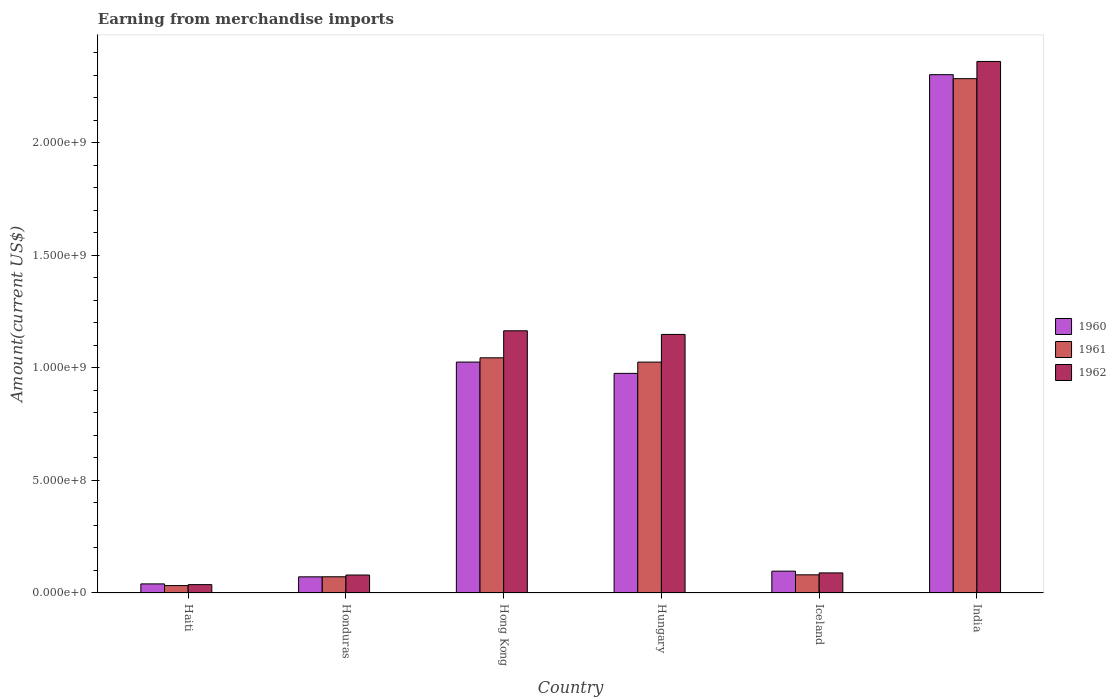Are the number of bars per tick equal to the number of legend labels?
Keep it short and to the point. Yes. Are the number of bars on each tick of the X-axis equal?
Your answer should be compact. Yes. How many bars are there on the 6th tick from the left?
Ensure brevity in your answer.  3. What is the label of the 1st group of bars from the left?
Provide a succinct answer. Haiti. What is the amount earned from merchandise imports in 1962 in India?
Ensure brevity in your answer.  2.36e+09. Across all countries, what is the maximum amount earned from merchandise imports in 1960?
Offer a terse response. 2.30e+09. Across all countries, what is the minimum amount earned from merchandise imports in 1961?
Provide a succinct answer. 3.29e+07. In which country was the amount earned from merchandise imports in 1960 maximum?
Your answer should be compact. India. In which country was the amount earned from merchandise imports in 1962 minimum?
Keep it short and to the point. Haiti. What is the total amount earned from merchandise imports in 1961 in the graph?
Your response must be concise. 4.54e+09. What is the difference between the amount earned from merchandise imports in 1961 in Hong Kong and that in Hungary?
Give a very brief answer. 1.91e+07. What is the difference between the amount earned from merchandise imports in 1961 in Haiti and the amount earned from merchandise imports in 1962 in Honduras?
Ensure brevity in your answer.  -4.69e+07. What is the average amount earned from merchandise imports in 1962 per country?
Offer a terse response. 8.14e+08. What is the difference between the amount earned from merchandise imports of/in 1961 and amount earned from merchandise imports of/in 1962 in Honduras?
Give a very brief answer. -7.75e+06. What is the ratio of the amount earned from merchandise imports in 1962 in Hungary to that in Iceland?
Your response must be concise. 12.87. Is the amount earned from merchandise imports in 1960 in Honduras less than that in Iceland?
Your answer should be compact. Yes. What is the difference between the highest and the second highest amount earned from merchandise imports in 1962?
Give a very brief answer. 1.20e+09. What is the difference between the highest and the lowest amount earned from merchandise imports in 1962?
Give a very brief answer. 2.32e+09. What does the 2nd bar from the left in Haiti represents?
Give a very brief answer. 1961. What does the 1st bar from the right in Hong Kong represents?
Offer a very short reply. 1962. Is it the case that in every country, the sum of the amount earned from merchandise imports in 1962 and amount earned from merchandise imports in 1960 is greater than the amount earned from merchandise imports in 1961?
Make the answer very short. Yes. How many bars are there?
Give a very brief answer. 18. What is the difference between two consecutive major ticks on the Y-axis?
Provide a short and direct response. 5.00e+08. Does the graph contain grids?
Provide a succinct answer. No. How many legend labels are there?
Make the answer very short. 3. How are the legend labels stacked?
Provide a succinct answer. Vertical. What is the title of the graph?
Offer a terse response. Earning from merchandise imports. Does "1962" appear as one of the legend labels in the graph?
Offer a terse response. Yes. What is the label or title of the X-axis?
Provide a short and direct response. Country. What is the label or title of the Y-axis?
Your response must be concise. Amount(current US$). What is the Amount(current US$) in 1960 in Haiti?
Your answer should be compact. 4.04e+07. What is the Amount(current US$) of 1961 in Haiti?
Offer a terse response. 3.29e+07. What is the Amount(current US$) in 1962 in Haiti?
Make the answer very short. 3.72e+07. What is the Amount(current US$) in 1960 in Honduras?
Provide a short and direct response. 7.18e+07. What is the Amount(current US$) in 1961 in Honduras?
Keep it short and to the point. 7.20e+07. What is the Amount(current US$) of 1962 in Honduras?
Provide a short and direct response. 7.98e+07. What is the Amount(current US$) in 1960 in Hong Kong?
Your response must be concise. 1.03e+09. What is the Amount(current US$) of 1961 in Hong Kong?
Your response must be concise. 1.05e+09. What is the Amount(current US$) in 1962 in Hong Kong?
Provide a succinct answer. 1.17e+09. What is the Amount(current US$) of 1960 in Hungary?
Ensure brevity in your answer.  9.76e+08. What is the Amount(current US$) of 1961 in Hungary?
Provide a succinct answer. 1.03e+09. What is the Amount(current US$) in 1962 in Hungary?
Your response must be concise. 1.15e+09. What is the Amount(current US$) in 1960 in Iceland?
Provide a succinct answer. 9.70e+07. What is the Amount(current US$) of 1961 in Iceland?
Ensure brevity in your answer.  8.08e+07. What is the Amount(current US$) in 1962 in Iceland?
Ensure brevity in your answer.  8.93e+07. What is the Amount(current US$) of 1960 in India?
Offer a very short reply. 2.30e+09. What is the Amount(current US$) in 1961 in India?
Ensure brevity in your answer.  2.29e+09. What is the Amount(current US$) of 1962 in India?
Your answer should be very brief. 2.36e+09. Across all countries, what is the maximum Amount(current US$) of 1960?
Your answer should be very brief. 2.30e+09. Across all countries, what is the maximum Amount(current US$) in 1961?
Ensure brevity in your answer.  2.29e+09. Across all countries, what is the maximum Amount(current US$) in 1962?
Provide a succinct answer. 2.36e+09. Across all countries, what is the minimum Amount(current US$) of 1960?
Offer a very short reply. 4.04e+07. Across all countries, what is the minimum Amount(current US$) of 1961?
Offer a terse response. 3.29e+07. Across all countries, what is the minimum Amount(current US$) of 1962?
Give a very brief answer. 3.72e+07. What is the total Amount(current US$) of 1960 in the graph?
Your answer should be compact. 4.51e+09. What is the total Amount(current US$) of 1961 in the graph?
Your answer should be compact. 4.54e+09. What is the total Amount(current US$) of 1962 in the graph?
Give a very brief answer. 4.88e+09. What is the difference between the Amount(current US$) of 1960 in Haiti and that in Honduras?
Offer a very short reply. -3.14e+07. What is the difference between the Amount(current US$) in 1961 in Haiti and that in Honduras?
Give a very brief answer. -3.92e+07. What is the difference between the Amount(current US$) of 1962 in Haiti and that in Honduras?
Ensure brevity in your answer.  -4.26e+07. What is the difference between the Amount(current US$) of 1960 in Haiti and that in Hong Kong?
Offer a terse response. -9.86e+08. What is the difference between the Amount(current US$) of 1961 in Haiti and that in Hong Kong?
Ensure brevity in your answer.  -1.01e+09. What is the difference between the Amount(current US$) in 1962 in Haiti and that in Hong Kong?
Provide a succinct answer. -1.13e+09. What is the difference between the Amount(current US$) in 1960 in Haiti and that in Hungary?
Your response must be concise. -9.36e+08. What is the difference between the Amount(current US$) in 1961 in Haiti and that in Hungary?
Offer a very short reply. -9.93e+08. What is the difference between the Amount(current US$) of 1962 in Haiti and that in Hungary?
Your answer should be very brief. -1.11e+09. What is the difference between the Amount(current US$) of 1960 in Haiti and that in Iceland?
Your answer should be compact. -5.66e+07. What is the difference between the Amount(current US$) of 1961 in Haiti and that in Iceland?
Your answer should be very brief. -4.79e+07. What is the difference between the Amount(current US$) of 1962 in Haiti and that in Iceland?
Make the answer very short. -5.21e+07. What is the difference between the Amount(current US$) in 1960 in Haiti and that in India?
Your response must be concise. -2.26e+09. What is the difference between the Amount(current US$) in 1961 in Haiti and that in India?
Offer a very short reply. -2.25e+09. What is the difference between the Amount(current US$) of 1962 in Haiti and that in India?
Provide a succinct answer. -2.32e+09. What is the difference between the Amount(current US$) of 1960 in Honduras and that in Hong Kong?
Ensure brevity in your answer.  -9.54e+08. What is the difference between the Amount(current US$) of 1961 in Honduras and that in Hong Kong?
Your answer should be very brief. -9.73e+08. What is the difference between the Amount(current US$) in 1962 in Honduras and that in Hong Kong?
Offer a very short reply. -1.09e+09. What is the difference between the Amount(current US$) in 1960 in Honduras and that in Hungary?
Offer a very short reply. -9.04e+08. What is the difference between the Amount(current US$) in 1961 in Honduras and that in Hungary?
Provide a short and direct response. -9.54e+08. What is the difference between the Amount(current US$) of 1962 in Honduras and that in Hungary?
Offer a very short reply. -1.07e+09. What is the difference between the Amount(current US$) in 1960 in Honduras and that in Iceland?
Your answer should be compact. -2.52e+07. What is the difference between the Amount(current US$) in 1961 in Honduras and that in Iceland?
Ensure brevity in your answer.  -8.71e+06. What is the difference between the Amount(current US$) of 1962 in Honduras and that in Iceland?
Keep it short and to the point. -9.50e+06. What is the difference between the Amount(current US$) in 1960 in Honduras and that in India?
Make the answer very short. -2.23e+09. What is the difference between the Amount(current US$) in 1961 in Honduras and that in India?
Your answer should be compact. -2.21e+09. What is the difference between the Amount(current US$) in 1962 in Honduras and that in India?
Provide a succinct answer. -2.28e+09. What is the difference between the Amount(current US$) of 1960 in Hong Kong and that in Hungary?
Offer a very short reply. 5.02e+07. What is the difference between the Amount(current US$) of 1961 in Hong Kong and that in Hungary?
Give a very brief answer. 1.91e+07. What is the difference between the Amount(current US$) in 1962 in Hong Kong and that in Hungary?
Your answer should be very brief. 1.62e+07. What is the difference between the Amount(current US$) in 1960 in Hong Kong and that in Iceland?
Your answer should be very brief. 9.29e+08. What is the difference between the Amount(current US$) in 1961 in Hong Kong and that in Iceland?
Provide a succinct answer. 9.64e+08. What is the difference between the Amount(current US$) in 1962 in Hong Kong and that in Iceland?
Offer a terse response. 1.08e+09. What is the difference between the Amount(current US$) of 1960 in Hong Kong and that in India?
Give a very brief answer. -1.28e+09. What is the difference between the Amount(current US$) of 1961 in Hong Kong and that in India?
Ensure brevity in your answer.  -1.24e+09. What is the difference between the Amount(current US$) of 1962 in Hong Kong and that in India?
Offer a terse response. -1.20e+09. What is the difference between the Amount(current US$) in 1960 in Hungary and that in Iceland?
Your response must be concise. 8.79e+08. What is the difference between the Amount(current US$) in 1961 in Hungary and that in Iceland?
Make the answer very short. 9.45e+08. What is the difference between the Amount(current US$) in 1962 in Hungary and that in Iceland?
Your response must be concise. 1.06e+09. What is the difference between the Amount(current US$) of 1960 in Hungary and that in India?
Make the answer very short. -1.33e+09. What is the difference between the Amount(current US$) in 1961 in Hungary and that in India?
Provide a succinct answer. -1.26e+09. What is the difference between the Amount(current US$) of 1962 in Hungary and that in India?
Offer a very short reply. -1.21e+09. What is the difference between the Amount(current US$) of 1960 in Iceland and that in India?
Offer a terse response. -2.21e+09. What is the difference between the Amount(current US$) of 1961 in Iceland and that in India?
Give a very brief answer. -2.20e+09. What is the difference between the Amount(current US$) of 1962 in Iceland and that in India?
Provide a short and direct response. -2.27e+09. What is the difference between the Amount(current US$) of 1960 in Haiti and the Amount(current US$) of 1961 in Honduras?
Your answer should be compact. -3.17e+07. What is the difference between the Amount(current US$) of 1960 in Haiti and the Amount(current US$) of 1962 in Honduras?
Keep it short and to the point. -3.94e+07. What is the difference between the Amount(current US$) in 1961 in Haiti and the Amount(current US$) in 1962 in Honduras?
Your answer should be compact. -4.69e+07. What is the difference between the Amount(current US$) of 1960 in Haiti and the Amount(current US$) of 1961 in Hong Kong?
Make the answer very short. -1.00e+09. What is the difference between the Amount(current US$) in 1960 in Haiti and the Amount(current US$) in 1962 in Hong Kong?
Provide a short and direct response. -1.12e+09. What is the difference between the Amount(current US$) of 1961 in Haiti and the Amount(current US$) of 1962 in Hong Kong?
Ensure brevity in your answer.  -1.13e+09. What is the difference between the Amount(current US$) in 1960 in Haiti and the Amount(current US$) in 1961 in Hungary?
Give a very brief answer. -9.86e+08. What is the difference between the Amount(current US$) in 1960 in Haiti and the Amount(current US$) in 1962 in Hungary?
Your answer should be very brief. -1.11e+09. What is the difference between the Amount(current US$) of 1961 in Haiti and the Amount(current US$) of 1962 in Hungary?
Make the answer very short. -1.12e+09. What is the difference between the Amount(current US$) in 1960 in Haiti and the Amount(current US$) in 1961 in Iceland?
Make the answer very short. -4.04e+07. What is the difference between the Amount(current US$) of 1960 in Haiti and the Amount(current US$) of 1962 in Iceland?
Provide a short and direct response. -4.89e+07. What is the difference between the Amount(current US$) in 1961 in Haiti and the Amount(current US$) in 1962 in Iceland?
Provide a short and direct response. -5.64e+07. What is the difference between the Amount(current US$) in 1960 in Haiti and the Amount(current US$) in 1961 in India?
Give a very brief answer. -2.25e+09. What is the difference between the Amount(current US$) in 1960 in Haiti and the Amount(current US$) in 1962 in India?
Give a very brief answer. -2.32e+09. What is the difference between the Amount(current US$) of 1961 in Haiti and the Amount(current US$) of 1962 in India?
Provide a short and direct response. -2.33e+09. What is the difference between the Amount(current US$) of 1960 in Honduras and the Amount(current US$) of 1961 in Hong Kong?
Your response must be concise. -9.73e+08. What is the difference between the Amount(current US$) of 1960 in Honduras and the Amount(current US$) of 1962 in Hong Kong?
Make the answer very short. -1.09e+09. What is the difference between the Amount(current US$) in 1961 in Honduras and the Amount(current US$) in 1962 in Hong Kong?
Your answer should be very brief. -1.09e+09. What is the difference between the Amount(current US$) of 1960 in Honduras and the Amount(current US$) of 1961 in Hungary?
Provide a short and direct response. -9.54e+08. What is the difference between the Amount(current US$) of 1960 in Honduras and the Amount(current US$) of 1962 in Hungary?
Offer a terse response. -1.08e+09. What is the difference between the Amount(current US$) of 1961 in Honduras and the Amount(current US$) of 1962 in Hungary?
Keep it short and to the point. -1.08e+09. What is the difference between the Amount(current US$) of 1960 in Honduras and the Amount(current US$) of 1961 in Iceland?
Ensure brevity in your answer.  -8.96e+06. What is the difference between the Amount(current US$) in 1960 in Honduras and the Amount(current US$) in 1962 in Iceland?
Your answer should be compact. -1.75e+07. What is the difference between the Amount(current US$) of 1961 in Honduras and the Amount(current US$) of 1962 in Iceland?
Ensure brevity in your answer.  -1.73e+07. What is the difference between the Amount(current US$) of 1960 in Honduras and the Amount(current US$) of 1961 in India?
Provide a succinct answer. -2.21e+09. What is the difference between the Amount(current US$) in 1960 in Honduras and the Amount(current US$) in 1962 in India?
Keep it short and to the point. -2.29e+09. What is the difference between the Amount(current US$) of 1961 in Honduras and the Amount(current US$) of 1962 in India?
Your response must be concise. -2.29e+09. What is the difference between the Amount(current US$) in 1960 in Hong Kong and the Amount(current US$) in 1962 in Hungary?
Make the answer very short. -1.23e+08. What is the difference between the Amount(current US$) in 1961 in Hong Kong and the Amount(current US$) in 1962 in Hungary?
Your answer should be compact. -1.04e+08. What is the difference between the Amount(current US$) in 1960 in Hong Kong and the Amount(current US$) in 1961 in Iceland?
Ensure brevity in your answer.  9.45e+08. What is the difference between the Amount(current US$) of 1960 in Hong Kong and the Amount(current US$) of 1962 in Iceland?
Give a very brief answer. 9.37e+08. What is the difference between the Amount(current US$) of 1961 in Hong Kong and the Amount(current US$) of 1962 in Iceland?
Give a very brief answer. 9.56e+08. What is the difference between the Amount(current US$) in 1960 in Hong Kong and the Amount(current US$) in 1961 in India?
Give a very brief answer. -1.26e+09. What is the difference between the Amount(current US$) of 1960 in Hong Kong and the Amount(current US$) of 1962 in India?
Make the answer very short. -1.34e+09. What is the difference between the Amount(current US$) in 1961 in Hong Kong and the Amount(current US$) in 1962 in India?
Your response must be concise. -1.32e+09. What is the difference between the Amount(current US$) in 1960 in Hungary and the Amount(current US$) in 1961 in Iceland?
Your response must be concise. 8.95e+08. What is the difference between the Amount(current US$) of 1960 in Hungary and the Amount(current US$) of 1962 in Iceland?
Provide a short and direct response. 8.87e+08. What is the difference between the Amount(current US$) in 1961 in Hungary and the Amount(current US$) in 1962 in Iceland?
Make the answer very short. 9.37e+08. What is the difference between the Amount(current US$) in 1960 in Hungary and the Amount(current US$) in 1961 in India?
Your answer should be compact. -1.31e+09. What is the difference between the Amount(current US$) in 1960 in Hungary and the Amount(current US$) in 1962 in India?
Provide a short and direct response. -1.39e+09. What is the difference between the Amount(current US$) of 1961 in Hungary and the Amount(current US$) of 1962 in India?
Your answer should be compact. -1.34e+09. What is the difference between the Amount(current US$) of 1960 in Iceland and the Amount(current US$) of 1961 in India?
Offer a terse response. -2.19e+09. What is the difference between the Amount(current US$) in 1960 in Iceland and the Amount(current US$) in 1962 in India?
Give a very brief answer. -2.27e+09. What is the difference between the Amount(current US$) of 1961 in Iceland and the Amount(current US$) of 1962 in India?
Provide a succinct answer. -2.28e+09. What is the average Amount(current US$) of 1960 per country?
Your answer should be very brief. 7.52e+08. What is the average Amount(current US$) of 1961 per country?
Keep it short and to the point. 7.57e+08. What is the average Amount(current US$) in 1962 per country?
Make the answer very short. 8.14e+08. What is the difference between the Amount(current US$) of 1960 and Amount(current US$) of 1961 in Haiti?
Your response must be concise. 7.52e+06. What is the difference between the Amount(current US$) in 1960 and Amount(current US$) in 1962 in Haiti?
Offer a very short reply. 3.23e+06. What is the difference between the Amount(current US$) in 1961 and Amount(current US$) in 1962 in Haiti?
Your answer should be very brief. -4.30e+06. What is the difference between the Amount(current US$) in 1960 and Amount(current US$) in 1961 in Honduras?
Offer a very short reply. -2.50e+05. What is the difference between the Amount(current US$) in 1960 and Amount(current US$) in 1962 in Honduras?
Your answer should be compact. -8.00e+06. What is the difference between the Amount(current US$) of 1961 and Amount(current US$) of 1962 in Honduras?
Ensure brevity in your answer.  -7.75e+06. What is the difference between the Amount(current US$) of 1960 and Amount(current US$) of 1961 in Hong Kong?
Offer a very short reply. -1.89e+07. What is the difference between the Amount(current US$) in 1960 and Amount(current US$) in 1962 in Hong Kong?
Give a very brief answer. -1.39e+08. What is the difference between the Amount(current US$) of 1961 and Amount(current US$) of 1962 in Hong Kong?
Offer a terse response. -1.20e+08. What is the difference between the Amount(current US$) in 1960 and Amount(current US$) in 1961 in Hungary?
Keep it short and to the point. -5.00e+07. What is the difference between the Amount(current US$) in 1960 and Amount(current US$) in 1962 in Hungary?
Keep it short and to the point. -1.73e+08. What is the difference between the Amount(current US$) in 1961 and Amount(current US$) in 1962 in Hungary?
Ensure brevity in your answer.  -1.23e+08. What is the difference between the Amount(current US$) of 1960 and Amount(current US$) of 1961 in Iceland?
Your response must be concise. 1.63e+07. What is the difference between the Amount(current US$) of 1960 and Amount(current US$) of 1962 in Iceland?
Give a very brief answer. 7.74e+06. What is the difference between the Amount(current US$) in 1961 and Amount(current US$) in 1962 in Iceland?
Offer a very short reply. -8.54e+06. What is the difference between the Amount(current US$) of 1960 and Amount(current US$) of 1961 in India?
Keep it short and to the point. 1.76e+07. What is the difference between the Amount(current US$) of 1960 and Amount(current US$) of 1962 in India?
Provide a short and direct response. -5.88e+07. What is the difference between the Amount(current US$) in 1961 and Amount(current US$) in 1962 in India?
Offer a terse response. -7.64e+07. What is the ratio of the Amount(current US$) of 1960 in Haiti to that in Honduras?
Your answer should be very brief. 0.56. What is the ratio of the Amount(current US$) of 1961 in Haiti to that in Honduras?
Keep it short and to the point. 0.46. What is the ratio of the Amount(current US$) of 1962 in Haiti to that in Honduras?
Offer a very short reply. 0.47. What is the ratio of the Amount(current US$) in 1960 in Haiti to that in Hong Kong?
Make the answer very short. 0.04. What is the ratio of the Amount(current US$) of 1961 in Haiti to that in Hong Kong?
Your response must be concise. 0.03. What is the ratio of the Amount(current US$) in 1962 in Haiti to that in Hong Kong?
Provide a short and direct response. 0.03. What is the ratio of the Amount(current US$) in 1960 in Haiti to that in Hungary?
Offer a very short reply. 0.04. What is the ratio of the Amount(current US$) in 1961 in Haiti to that in Hungary?
Your answer should be very brief. 0.03. What is the ratio of the Amount(current US$) in 1962 in Haiti to that in Hungary?
Offer a terse response. 0.03. What is the ratio of the Amount(current US$) of 1960 in Haiti to that in Iceland?
Your answer should be compact. 0.42. What is the ratio of the Amount(current US$) in 1961 in Haiti to that in Iceland?
Your answer should be compact. 0.41. What is the ratio of the Amount(current US$) in 1962 in Haiti to that in Iceland?
Your answer should be very brief. 0.42. What is the ratio of the Amount(current US$) in 1960 in Haiti to that in India?
Give a very brief answer. 0.02. What is the ratio of the Amount(current US$) of 1961 in Haiti to that in India?
Make the answer very short. 0.01. What is the ratio of the Amount(current US$) of 1962 in Haiti to that in India?
Your answer should be compact. 0.02. What is the ratio of the Amount(current US$) in 1960 in Honduras to that in Hong Kong?
Keep it short and to the point. 0.07. What is the ratio of the Amount(current US$) in 1961 in Honduras to that in Hong Kong?
Offer a very short reply. 0.07. What is the ratio of the Amount(current US$) of 1962 in Honduras to that in Hong Kong?
Ensure brevity in your answer.  0.07. What is the ratio of the Amount(current US$) in 1960 in Honduras to that in Hungary?
Your response must be concise. 0.07. What is the ratio of the Amount(current US$) in 1961 in Honduras to that in Hungary?
Make the answer very short. 0.07. What is the ratio of the Amount(current US$) in 1962 in Honduras to that in Hungary?
Provide a short and direct response. 0.07. What is the ratio of the Amount(current US$) of 1960 in Honduras to that in Iceland?
Provide a succinct answer. 0.74. What is the ratio of the Amount(current US$) of 1961 in Honduras to that in Iceland?
Offer a terse response. 0.89. What is the ratio of the Amount(current US$) in 1962 in Honduras to that in Iceland?
Provide a succinct answer. 0.89. What is the ratio of the Amount(current US$) of 1960 in Honduras to that in India?
Give a very brief answer. 0.03. What is the ratio of the Amount(current US$) of 1961 in Honduras to that in India?
Provide a short and direct response. 0.03. What is the ratio of the Amount(current US$) in 1962 in Honduras to that in India?
Provide a succinct answer. 0.03. What is the ratio of the Amount(current US$) in 1960 in Hong Kong to that in Hungary?
Keep it short and to the point. 1.05. What is the ratio of the Amount(current US$) of 1961 in Hong Kong to that in Hungary?
Offer a very short reply. 1.02. What is the ratio of the Amount(current US$) in 1962 in Hong Kong to that in Hungary?
Your answer should be compact. 1.01. What is the ratio of the Amount(current US$) in 1960 in Hong Kong to that in Iceland?
Give a very brief answer. 10.57. What is the ratio of the Amount(current US$) in 1961 in Hong Kong to that in Iceland?
Offer a terse response. 12.94. What is the ratio of the Amount(current US$) in 1962 in Hong Kong to that in Iceland?
Offer a very short reply. 13.05. What is the ratio of the Amount(current US$) in 1960 in Hong Kong to that in India?
Ensure brevity in your answer.  0.45. What is the ratio of the Amount(current US$) of 1961 in Hong Kong to that in India?
Make the answer very short. 0.46. What is the ratio of the Amount(current US$) of 1962 in Hong Kong to that in India?
Provide a short and direct response. 0.49. What is the ratio of the Amount(current US$) in 1960 in Hungary to that in Iceland?
Your answer should be very brief. 10.06. What is the ratio of the Amount(current US$) of 1961 in Hungary to that in Iceland?
Ensure brevity in your answer.  12.7. What is the ratio of the Amount(current US$) in 1962 in Hungary to that in Iceland?
Offer a very short reply. 12.87. What is the ratio of the Amount(current US$) in 1960 in Hungary to that in India?
Your answer should be compact. 0.42. What is the ratio of the Amount(current US$) of 1961 in Hungary to that in India?
Provide a short and direct response. 0.45. What is the ratio of the Amount(current US$) of 1962 in Hungary to that in India?
Ensure brevity in your answer.  0.49. What is the ratio of the Amount(current US$) of 1960 in Iceland to that in India?
Give a very brief answer. 0.04. What is the ratio of the Amount(current US$) of 1961 in Iceland to that in India?
Offer a very short reply. 0.04. What is the ratio of the Amount(current US$) of 1962 in Iceland to that in India?
Offer a very short reply. 0.04. What is the difference between the highest and the second highest Amount(current US$) of 1960?
Ensure brevity in your answer.  1.28e+09. What is the difference between the highest and the second highest Amount(current US$) in 1961?
Offer a terse response. 1.24e+09. What is the difference between the highest and the second highest Amount(current US$) in 1962?
Keep it short and to the point. 1.20e+09. What is the difference between the highest and the lowest Amount(current US$) of 1960?
Your answer should be very brief. 2.26e+09. What is the difference between the highest and the lowest Amount(current US$) in 1961?
Your answer should be compact. 2.25e+09. What is the difference between the highest and the lowest Amount(current US$) in 1962?
Your answer should be compact. 2.32e+09. 